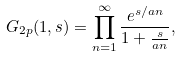<formula> <loc_0><loc_0><loc_500><loc_500>G _ { 2 p } ( 1 , s ) = \prod _ { n = 1 } ^ { \infty } \frac { e ^ { s / a n } } { 1 + \frac { s } { a n } } ,</formula> 